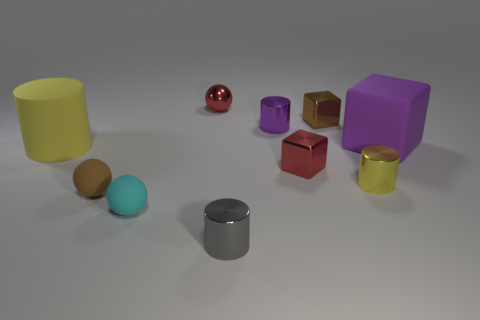Subtract all gray cylinders. How many cylinders are left? 3 Subtract all big cylinders. How many cylinders are left? 3 Subtract 2 cylinders. How many cylinders are left? 2 Subtract all cylinders. How many objects are left? 6 Subtract all green cylinders. Subtract all gray blocks. How many cylinders are left? 4 Add 10 large brown objects. How many large brown objects exist? 10 Subtract 0 green blocks. How many objects are left? 10 Subtract all gray cylinders. Subtract all matte blocks. How many objects are left? 8 Add 7 shiny blocks. How many shiny blocks are left? 9 